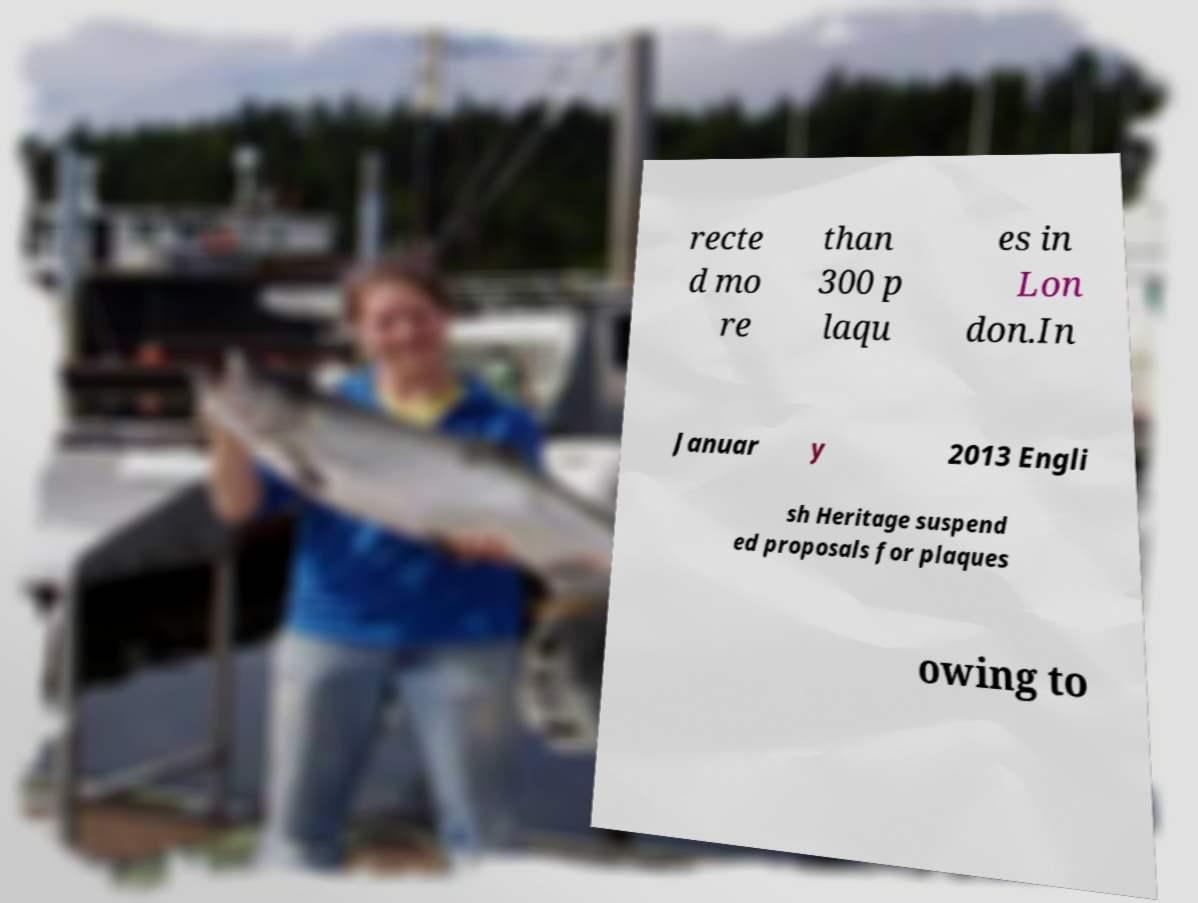Please read and relay the text visible in this image. What does it say? recte d mo re than 300 p laqu es in Lon don.In Januar y 2013 Engli sh Heritage suspend ed proposals for plaques owing to 